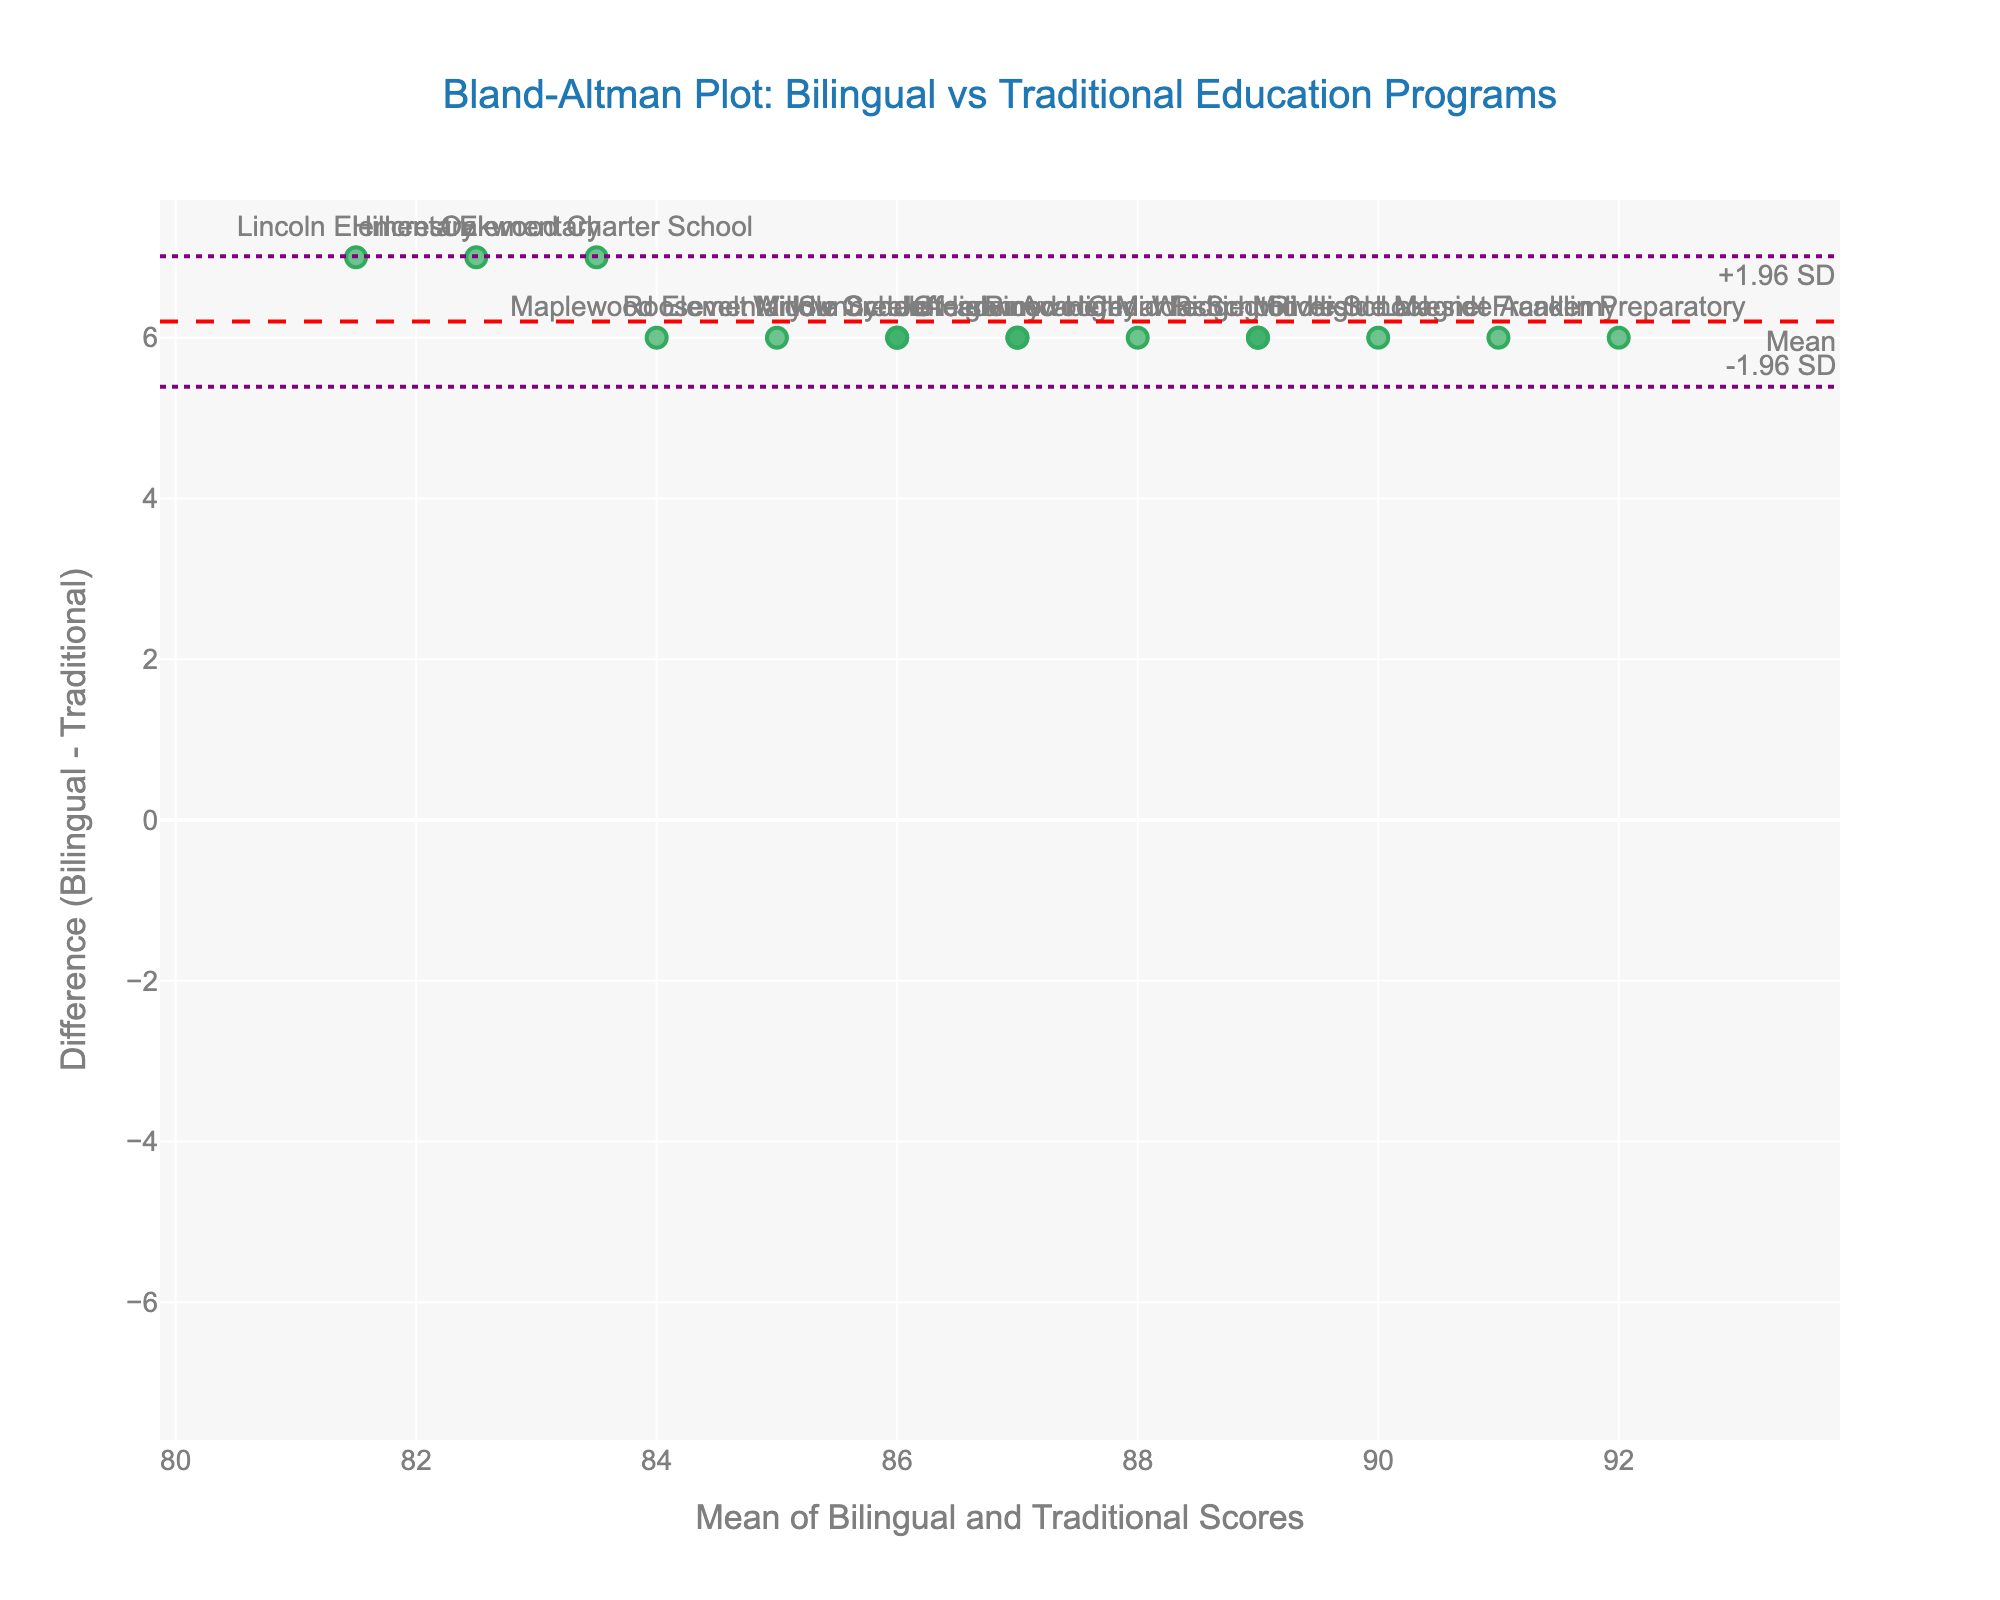what is the title of the plot? The title of the plot is displayed clearly at the top. It reads "Bland-Altman Plot: Bilingual vs Traditional Education Programs"
Answer: Bland-Altman Plot: Bilingual vs Traditional Education Programs how many schools are represented in the plot? Each point in the plot represents a school. By counting these points, you can determine the number of schools. There are 15 schools represented
Answer: 15 what is the callout position for measurements -1.96 SD and + 1.96 SD? The callout positions for -1.96 SD and +1.96 SD are displayed right next to their corresponding horizontal lines. The callout text "-1.96 SD" appears at the top right while "+1.96 SD" appears at the bottom right
Answer: top right ( -1.96 SD) and bottom right (+1.96 SD) which school has the widest positive difference between its bilingual and traditional program scores? To find the school with the widest positive difference, look at the highest point in the plot's Y-axis, where the difference is maximal. "Franklin Preparatory" has the widest positive difference.
Answer: Franklin Preparatory how many schools have a negative score difference? A negative score difference is represented by points below the y=0 horizontal line. There are no points below this line.
Answer: 0 what is the average of bilingual and traditional scores for Pinewood Middle School? The average for Pinewood Middle school is plotted on the X-axis. Find "Pinewood Middle School" among the labels and note its horizontal position. The average score for Pinewood Middle School is 88
Answer: 88 what is the mean difference between bilingual and traditional program scores? The mean difference is displayed with a dashed red horizontal line labeled "Mean". It's value is approximately 6. It represents the average of all differences plotted.
Answer: 6 what is the standard deviation of the differences? The standard deviation is represented by the distance of the 1.96 SD lines from the mean line. Each SD band is captured using visual interpretation. Approximate ±1.96 SD to analyze SD estimation: mean + (1.96 * SD) = ~16 and mean - (1.96 * SD) = ~6. The difference, here, 10, divided by 3.92 gives SD ~2.55
Answer: ~2.55 which school lies closest to the mean difference line? Identify the point that lies nearest to the horizontal dashed red line labeled "Mean". "Greenwood High" appears closest to the mean difference line.
Answer: Greenwood High 